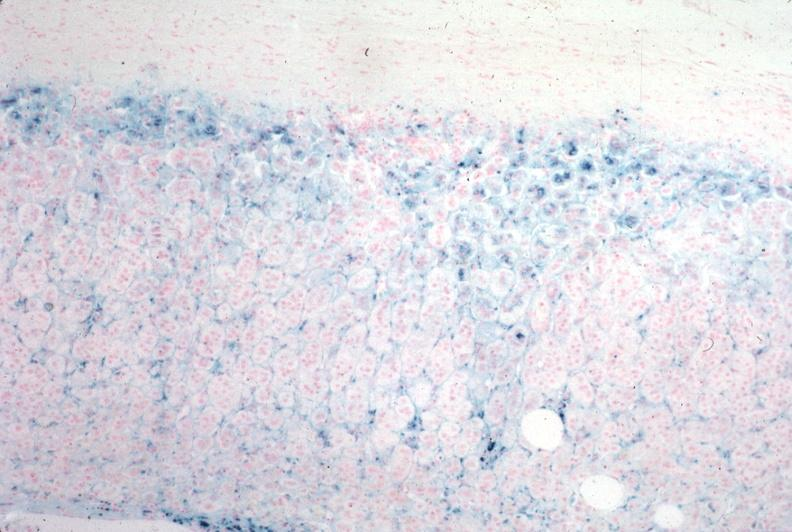what stain?
Answer the question using a single word or phrase. Iron 